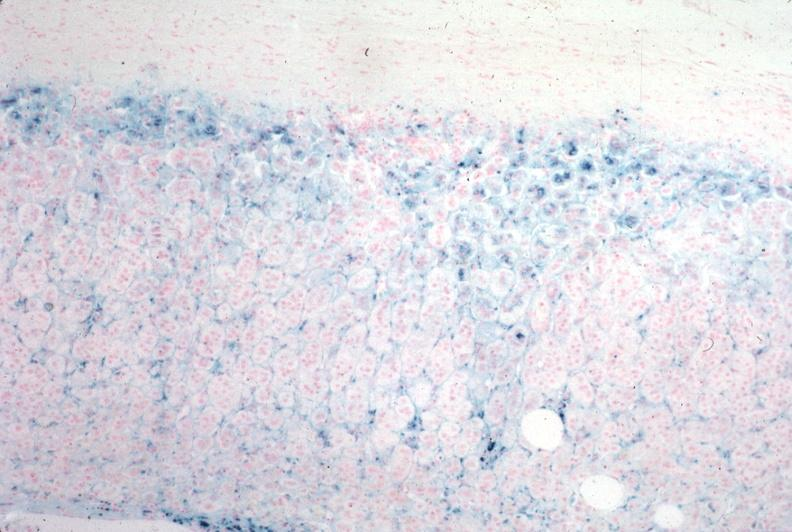what stain?
Answer the question using a single word or phrase. Iron 